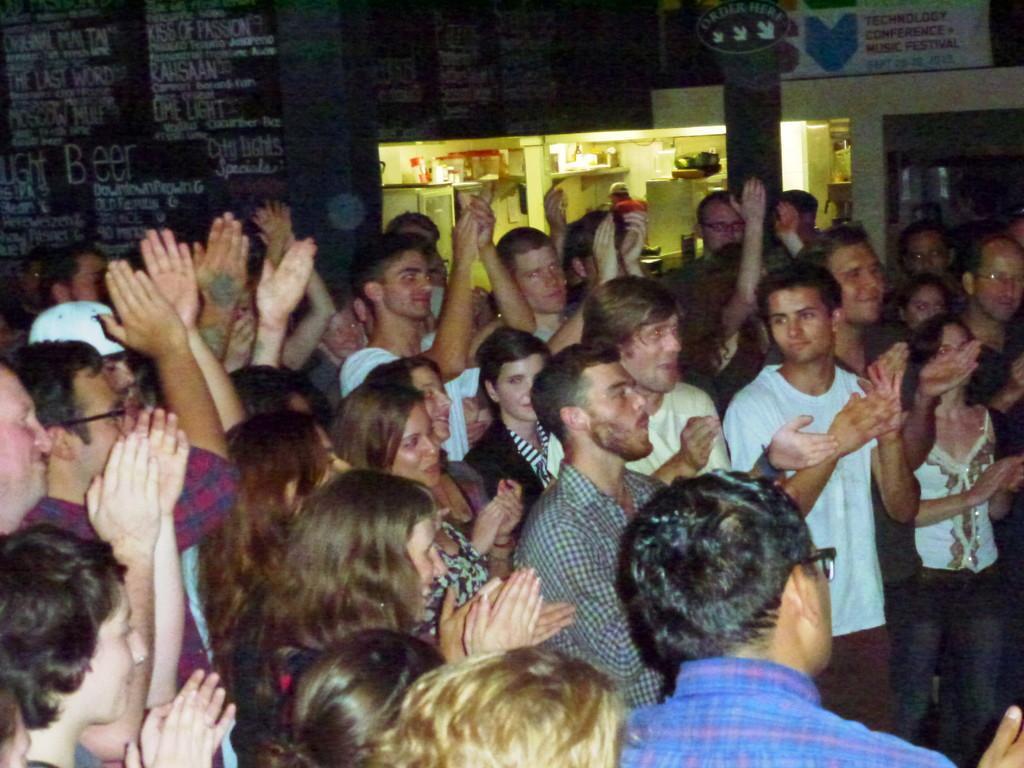Describe this image in one or two sentences. In this image at the bottom there are a group of people who are standing and they are clapping. In the background there are some boards, poles, lights and some other objects. 